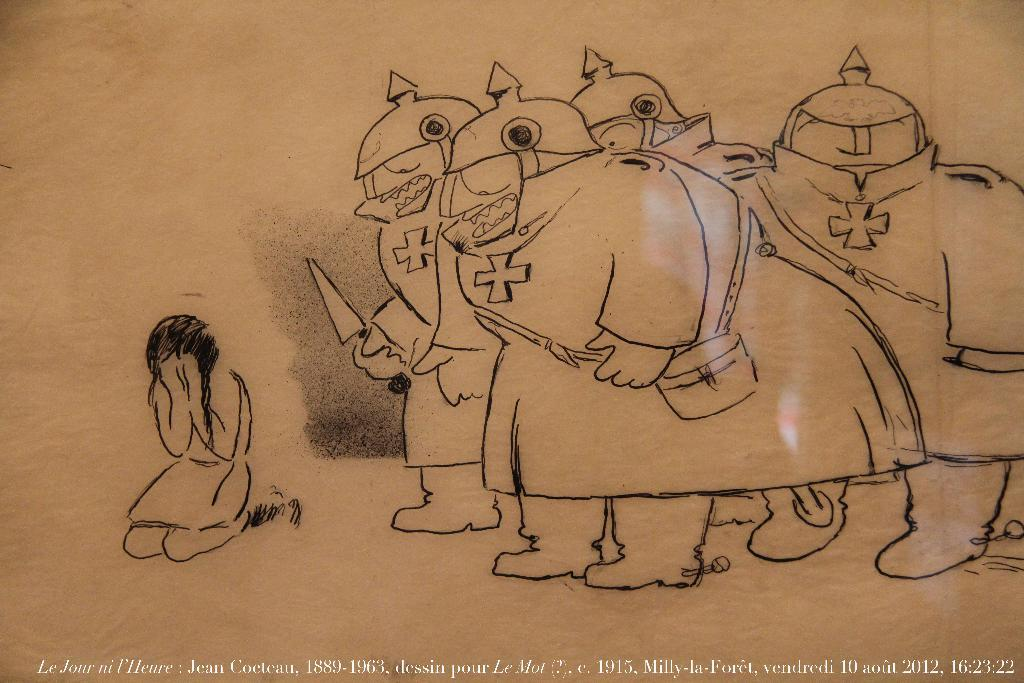What is the girl in the image doing? The girl is kneeling and crying in the image. What are the soldiers in the image holding? The soldiers in the image are holding swords. Are the soldiers sitting or standing in the image? The soldiers are standing in the image. What type of bait is the goat using to catch fish in the image? There is no goat or fishing activity present in the image. What school subject is being taught in the image? The image does not depict any educational setting or subject matter. 